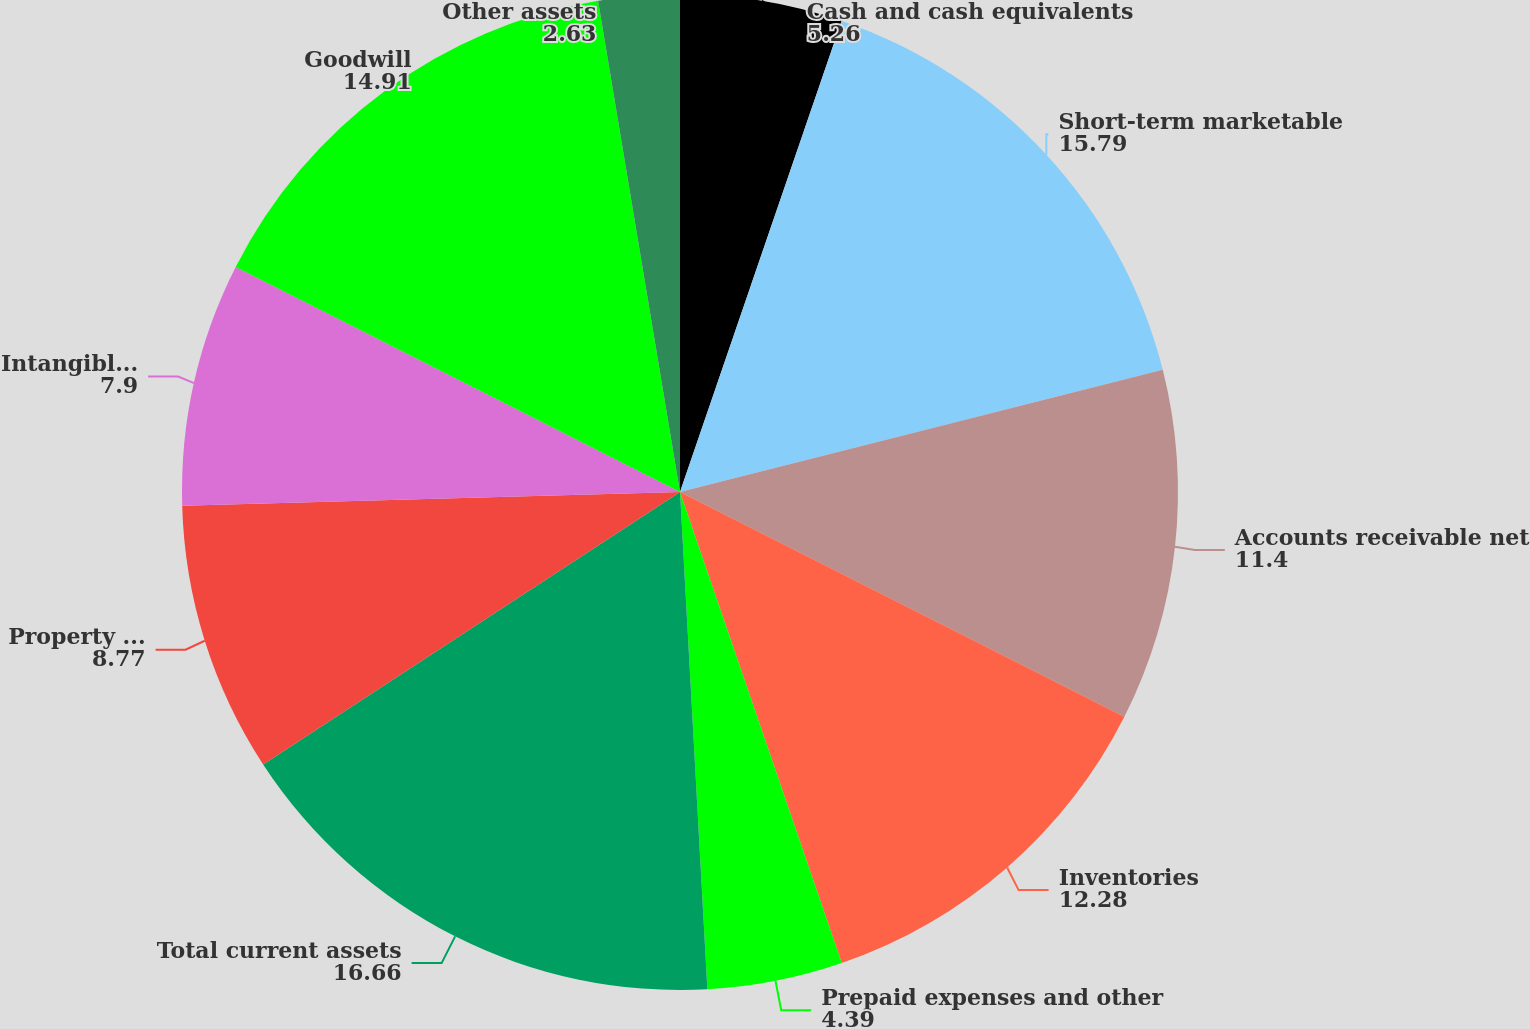Convert chart to OTSL. <chart><loc_0><loc_0><loc_500><loc_500><pie_chart><fcel>Cash and cash equivalents<fcel>Short-term marketable<fcel>Accounts receivable net<fcel>Inventories<fcel>Prepaid expenses and other<fcel>Total current assets<fcel>Property and equipment net<fcel>Intangible assets net<fcel>Goodwill<fcel>Other assets<nl><fcel>5.26%<fcel>15.79%<fcel>11.4%<fcel>12.28%<fcel>4.39%<fcel>16.66%<fcel>8.77%<fcel>7.9%<fcel>14.91%<fcel>2.63%<nl></chart> 